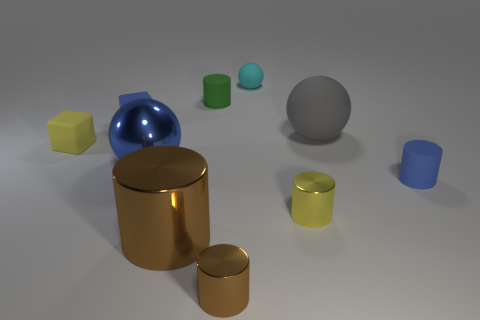What number of cylinders have the same color as the shiny sphere?
Give a very brief answer. 1. Are there fewer tiny blue cubes in front of the yellow matte block than yellow cubes that are right of the tiny blue cylinder?
Keep it short and to the point. No. There is a brown cylinder that is to the left of the green matte cylinder; what size is it?
Offer a very short reply. Large. What is the size of the other cylinder that is the same color as the big cylinder?
Make the answer very short. Small. Is there another big sphere that has the same material as the blue sphere?
Give a very brief answer. No. Does the small brown object have the same material as the green cylinder?
Your response must be concise. No. What is the color of the ball that is the same size as the green thing?
Make the answer very short. Cyan. What number of other objects are there of the same shape as the small yellow shiny object?
Your answer should be compact. 4. There is a blue matte cube; is its size the same as the yellow object in front of the tiny blue cylinder?
Keep it short and to the point. Yes. How many objects are blue metallic spheres or big gray metallic things?
Ensure brevity in your answer.  1. 